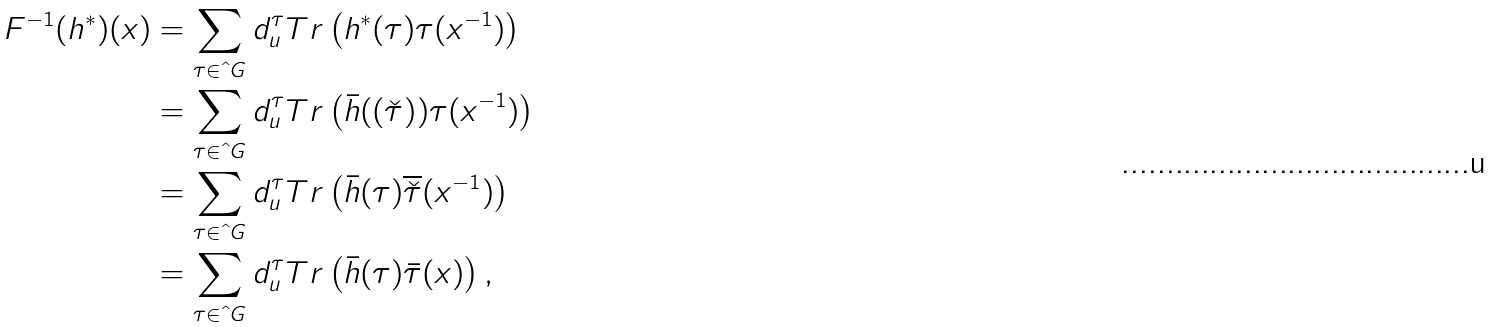Convert formula to latex. <formula><loc_0><loc_0><loc_500><loc_500>\ F ^ { - 1 } ( h ^ { * } ) ( x ) & = \sum _ { \tau \in \hat { \ } G } d _ { u } ^ { \tau } T r \left ( h ^ { * } ( \tau ) \tau ( x ^ { - 1 } ) \right ) \\ & = \sum _ { \tau \in \hat { \ } G } d _ { u } ^ { \tau } T r \left ( \bar { h } ( ( \check { \tau } ) ^ { } ) \tau ( x ^ { - 1 } ) \right ) \\ & = \sum _ { \tau \in \hat { \ } G } d _ { u } ^ { \tau } T r \left ( \bar { h } ( \tau ) \overline { \check { \tau } } ( x ^ { - 1 } ) \right ) \\ & = \sum _ { \tau \in \hat { \ } G } d _ { u } ^ { \tau } T r \left ( \bar { h } ( \tau ) \bar { \tau } ( x ) \right ) ,</formula> 